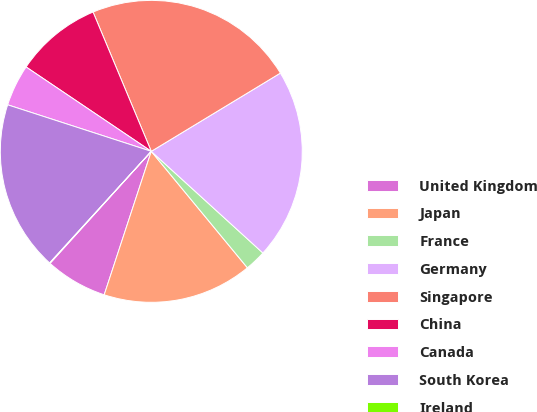Convert chart. <chart><loc_0><loc_0><loc_500><loc_500><pie_chart><fcel>United Kingdom<fcel>Japan<fcel>France<fcel>Germany<fcel>Singapore<fcel>China<fcel>Canada<fcel>South Korea<fcel>Ireland<nl><fcel>6.65%<fcel>16.03%<fcel>2.26%<fcel>20.43%<fcel>22.63%<fcel>9.26%<fcel>4.45%<fcel>18.23%<fcel>0.06%<nl></chart> 